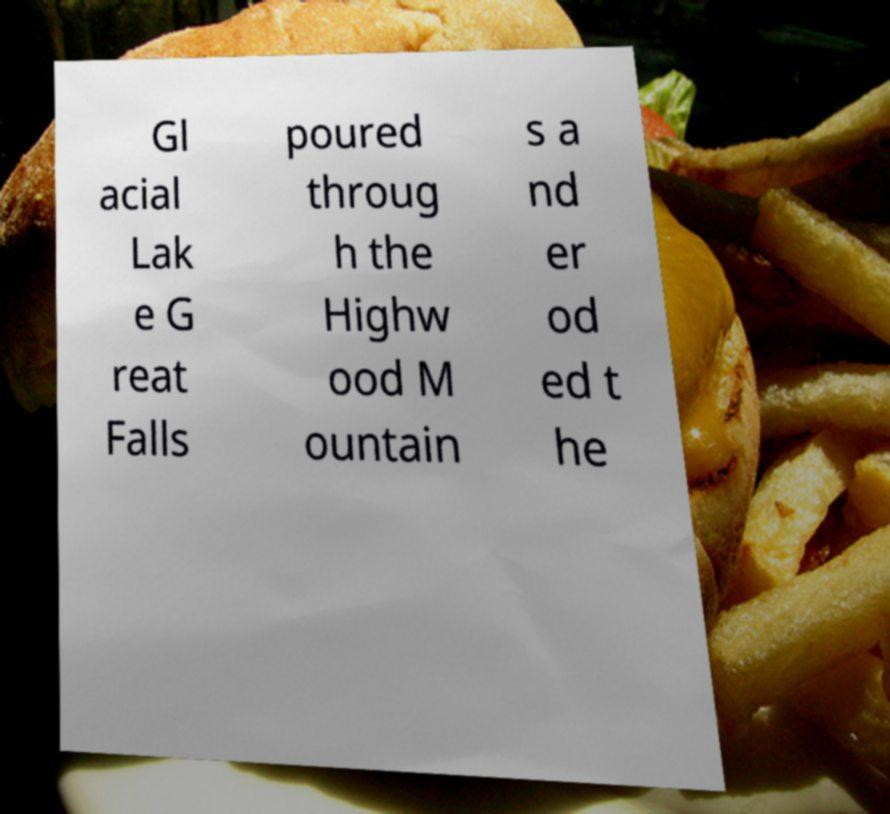Could you extract and type out the text from this image? Gl acial Lak e G reat Falls poured throug h the Highw ood M ountain s a nd er od ed t he 